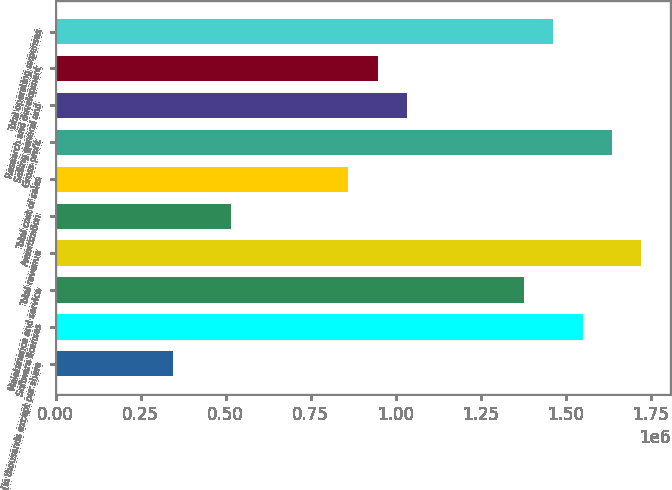<chart> <loc_0><loc_0><loc_500><loc_500><bar_chart><fcel>(in thousands except per share<fcel>Software licenses<fcel>Maintenance and service<fcel>Total revenue<fcel>Amortization<fcel>Total cost of sales<fcel>Gross profit<fcel>Selling general and<fcel>Research and development<fcel>Total operating expenses<nl><fcel>344506<fcel>1.55027e+06<fcel>1.37801e+06<fcel>1.72252e+06<fcel>516757<fcel>861260<fcel>1.63639e+06<fcel>1.03351e+06<fcel>947386<fcel>1.46414e+06<nl></chart> 